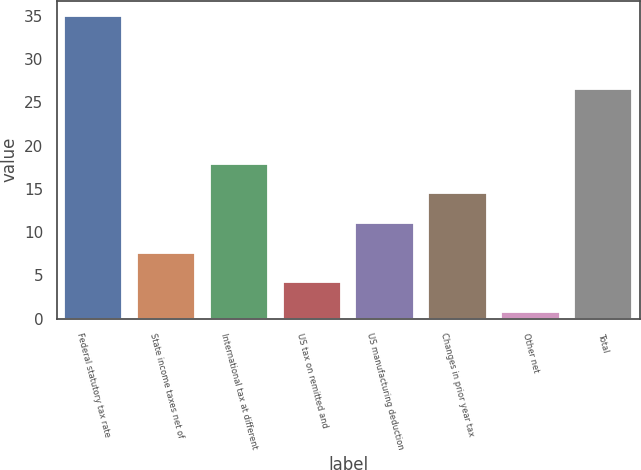Convert chart to OTSL. <chart><loc_0><loc_0><loc_500><loc_500><bar_chart><fcel>Federal statutory tax rate<fcel>State income taxes net of<fcel>International tax at different<fcel>US tax on remitted and<fcel>US manufacturing deduction<fcel>Changes in prior year tax<fcel>Other net<fcel>Total<nl><fcel>35<fcel>7.64<fcel>17.9<fcel>4.22<fcel>11.06<fcel>14.48<fcel>0.8<fcel>26.5<nl></chart> 